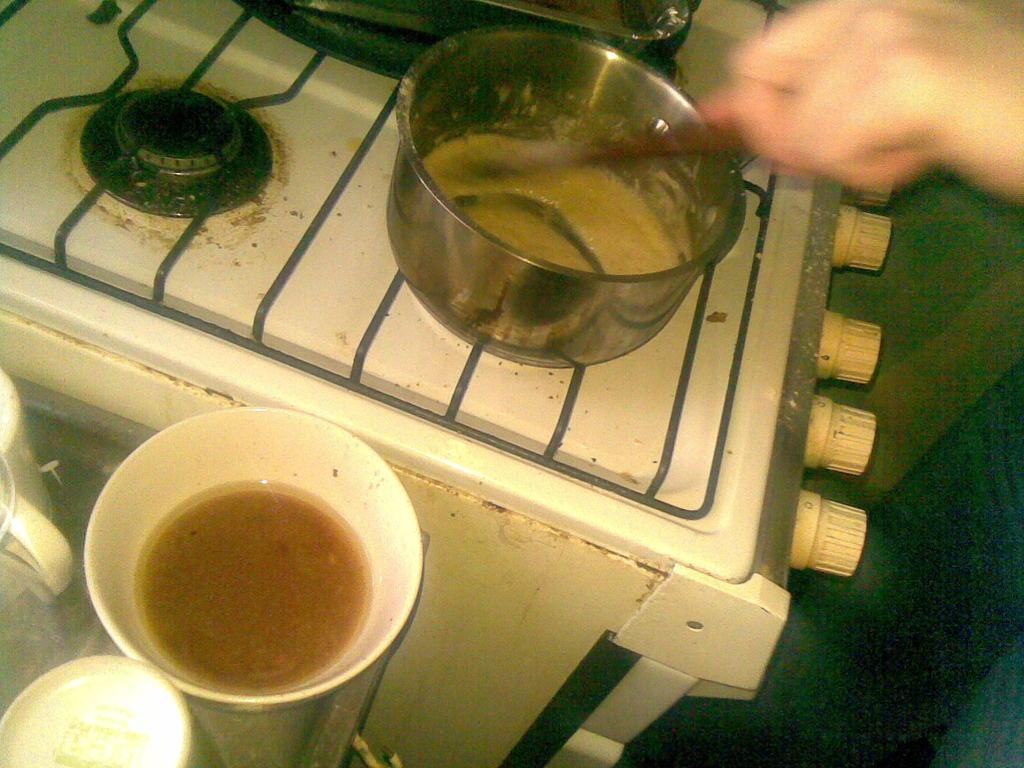How would you summarize this image in a sentence or two? In the image we can see a human hand holding a spoon. There is a stove, on it there is a metal container. We can even see there are other objects, white in color. 